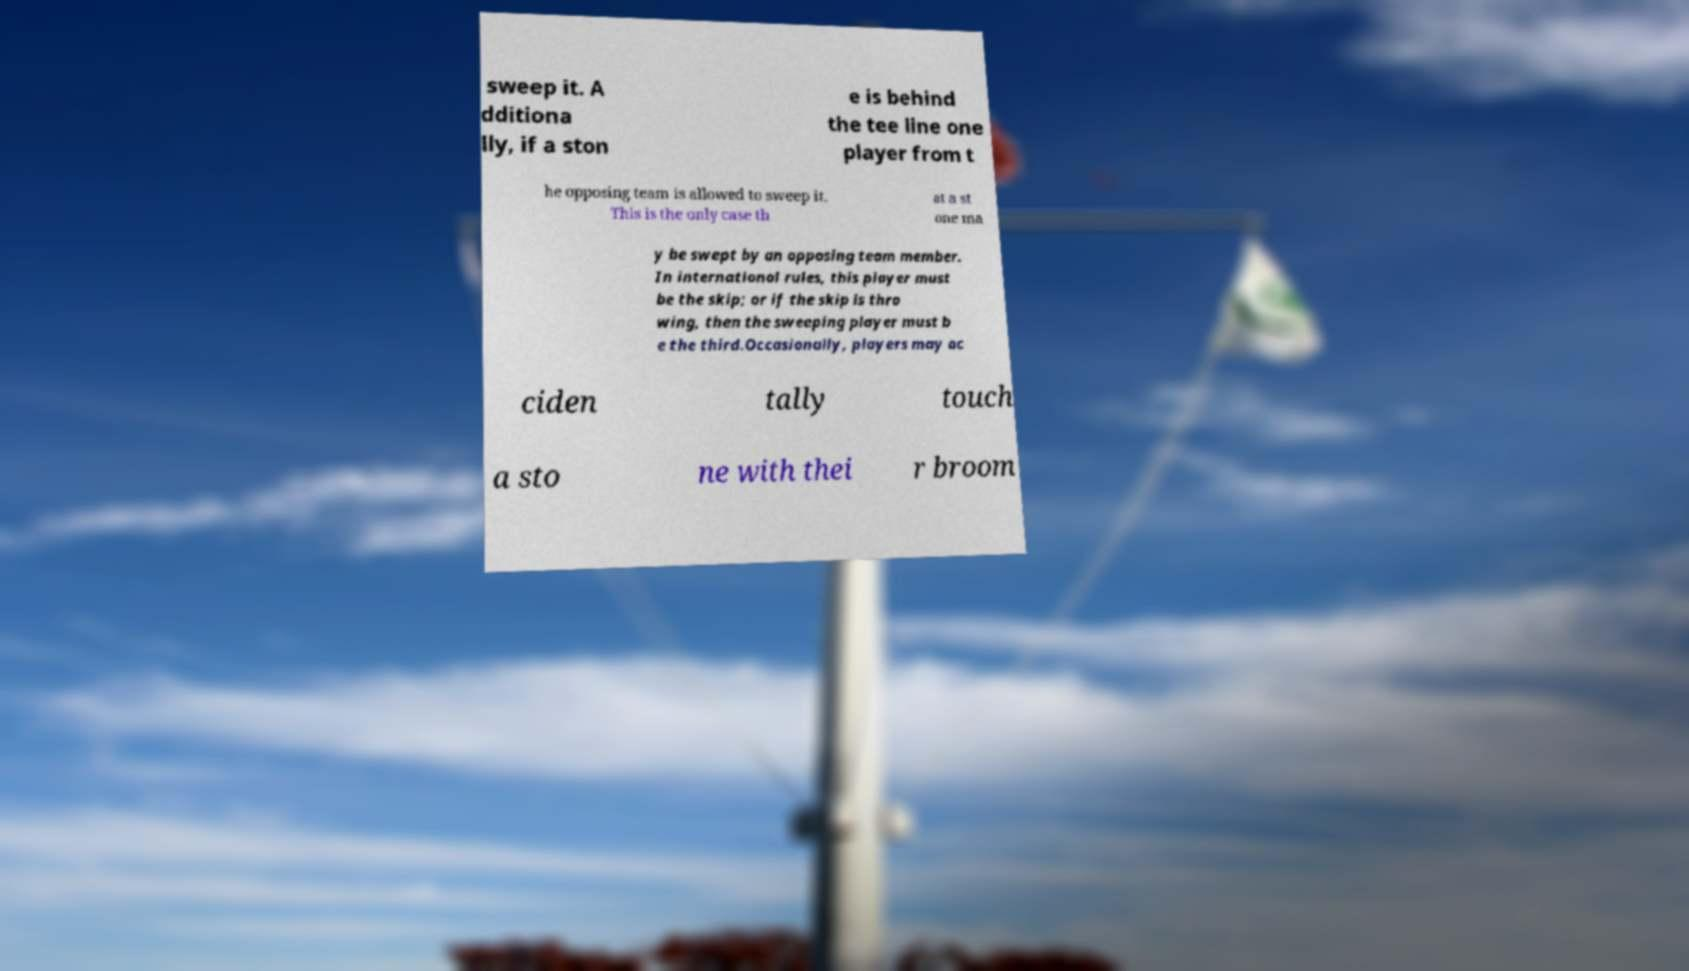Could you assist in decoding the text presented in this image and type it out clearly? sweep it. A dditiona lly, if a ston e is behind the tee line one player from t he opposing team is allowed to sweep it. This is the only case th at a st one ma y be swept by an opposing team member. In international rules, this player must be the skip; or if the skip is thro wing, then the sweeping player must b e the third.Occasionally, players may ac ciden tally touch a sto ne with thei r broom 